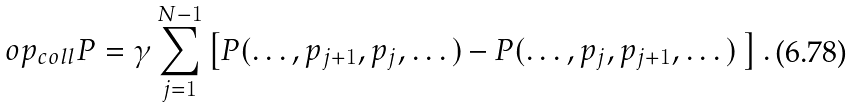<formula> <loc_0><loc_0><loc_500><loc_500>\L o p _ { c o l l } P = \gamma \sum _ { j = 1 } ^ { N - 1 } \left [ P ( \dots , p _ { j + 1 } , p _ { j } , \dots ) - P ( \dots , p _ { j } , p _ { j + 1 } , \dots ) \ \right ] .</formula> 